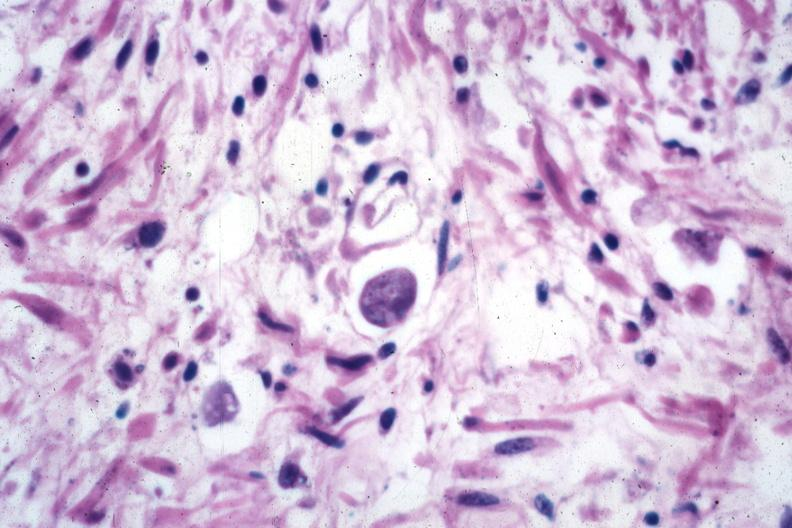where is this from?
Answer the question using a single word or phrase. Gastrointestinal system 